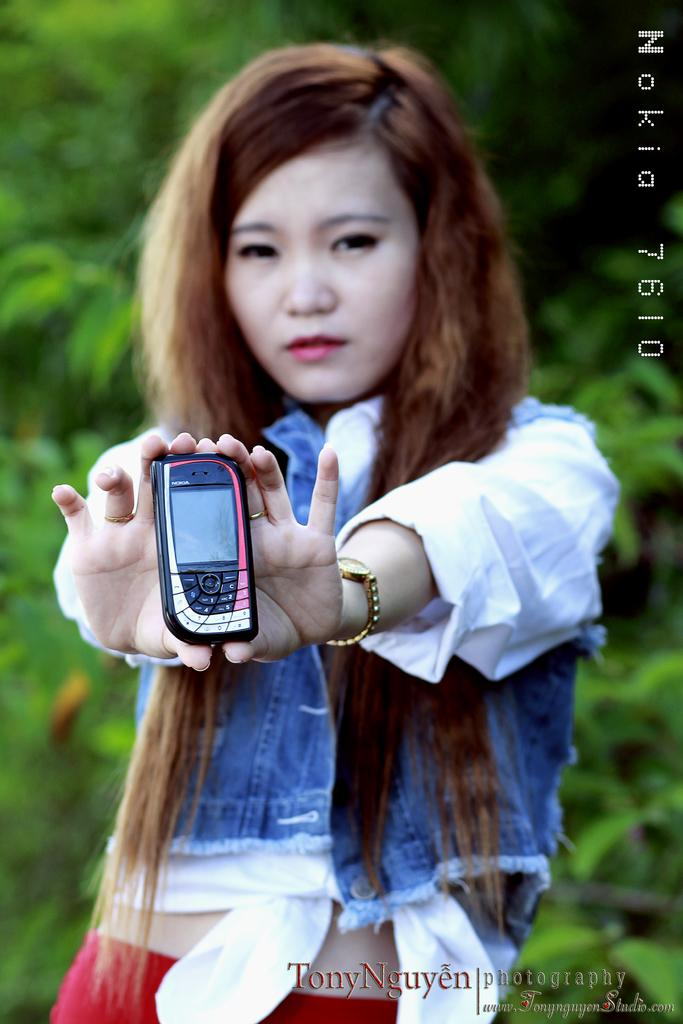Who is the main subject in the image? There is a girl in the image. What is the girl wearing? The girl is wearing a blue jacket and a white shirt. What is the girl holding in her hand? The girl is holding a mobile phone in her hand. What accessory is visible on the girl's left hand? There is a watch on the girl's left hand. What can be seen in the background of the image? There are trees in the background of the image. What type of bottle is being used as a base for the scene in the image? There is no bottle or scene present in the image; it features a girl wearing a blue jacket, a white shirt, holding a mobile phone, and wearing a watch, with trees in the background. 